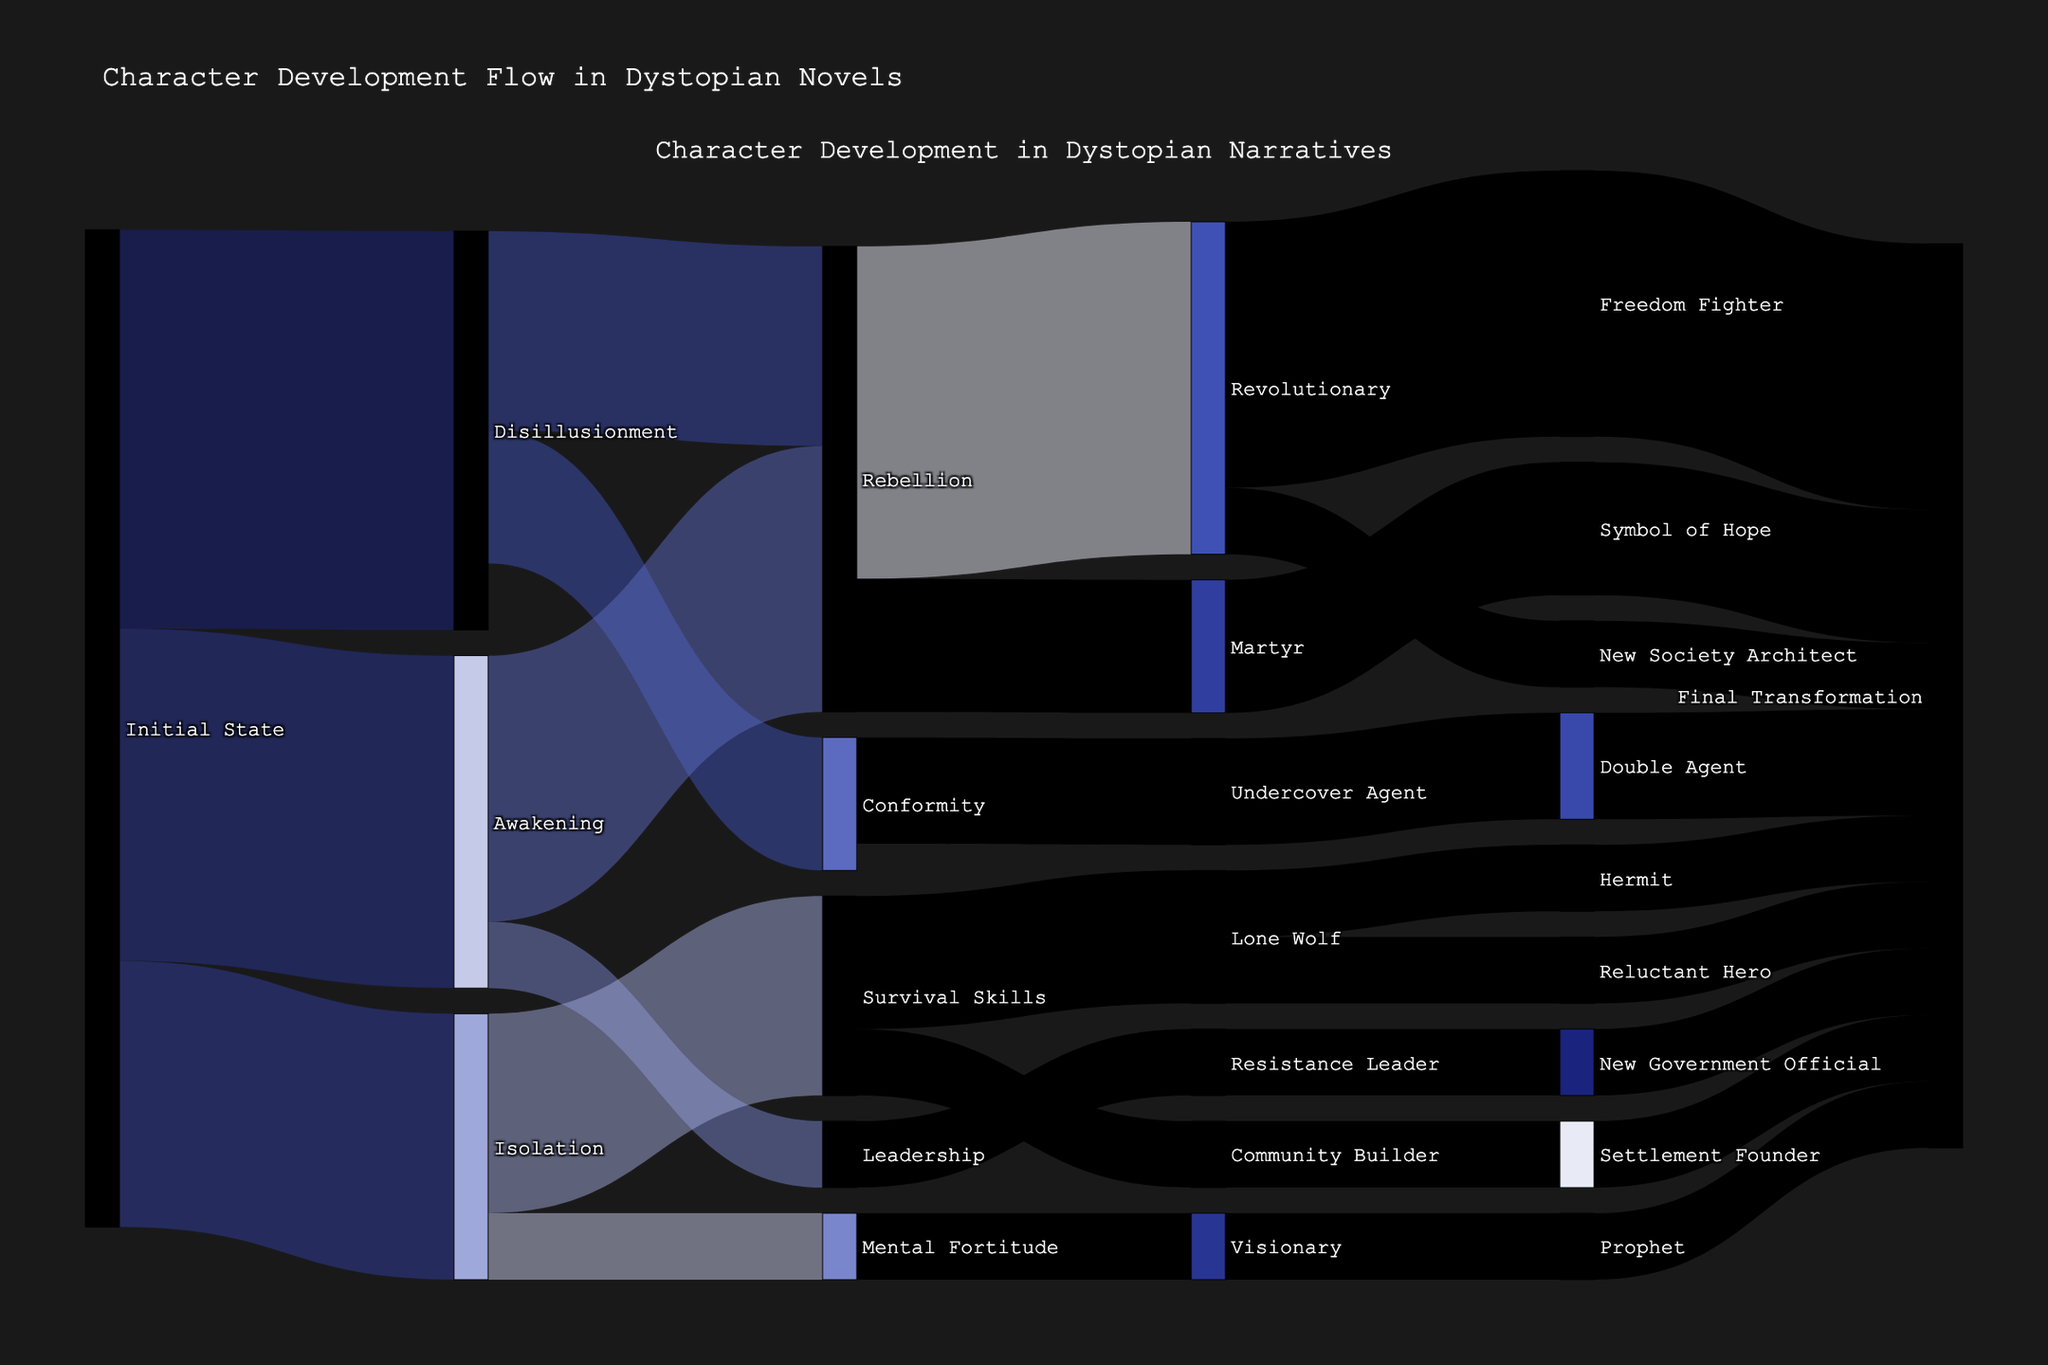How many unique character states are depicted in the flowchart? Count all the unique nodes present in the Sankey diagram, which are the character states. Each character state would be a node in the diagram, and they are represented uniquely by their labels.
Answer: 23 What is the most common initial state for characters in the diagram? Look for the sources of the links that appear most frequently at the beginning of the flows. In this case, "Initial State" appears most frequently.
Answer: Initial State Which final transformation state receives the most flow? Identify the target nodes labeled "Final Transformation." Sum up the values flowing into each "Final Transformation" node and compare them. The node receiving the largest total value is the answer.
Answer: Final Transformation (20 from Freedom Fighter, 5 from New Society Architect, 10 from Symbol of Hope, 8 from Double Agent, 5 from New Government Official, 5 from Hermit, 5 from Reluctant Hero, 5 from Settlement Founder, 5 from Prophet) = 68 What is the total value of characters that end in the "Rebellion" state from "Disillusionment" and "Awakening"? Look for the links leading from "Disillusionment" to "Rebellion" (value is 15) and from "Awakening" to "Rebellion" (value is 20). Add these values together.
Answer: 35 Compare the flow values from "Rebellion" to "Freedom Fighter" and "Martyr." Which one has a higher value? Locate the links flowing from "Rebellion" to "Freedom Fighter" (value is 20) and "Rebellion" to "Martyr" (value is 10). Compare these values.
Answer: Freedom Fighter (20) What value flows from "Leadership" to "Resistance Leader"? Identify the link connecting "Leadership" to "Resistance Leader" and note the value associated with it.
Answer: 5 How many transformation paths contribute to a character becoming a "Visionary"? Find the links where "Visionary" is the target and note the number of such links from different sources. In this case, there's only one link from "Mental Fortitude" to "Visionary."
Answer: 1 From "Isolation," which state receives a lower flow: "Survival Skills" or "Mental Fortitude"? Locate the links from "Isolation" to both "Survival Skills" (value is 15) and "Mental Fortitude" (value is 5). Compare the values.
Answer: Mental Fortitude (5) Which transformation has a higher total flow: those starting from "Awakening" or "Isolation"? Sum up all the values that flow out of "Awakening" (to Rebellion: 20, to Leadership: 5, total: 25) and all the flows out of "Isolation" (to Survival Skills: 15, to Mental Fortitude: 5, total: 20). Compare these totals.
Answer: Awakening What is the total flow from "Survival Skills"? Identify and sum all the values flowing from "Survival Skills" to its targets, which are "Lone Wolf" (10) and "Community Builder" (5). Add these values together.
Answer: 15 